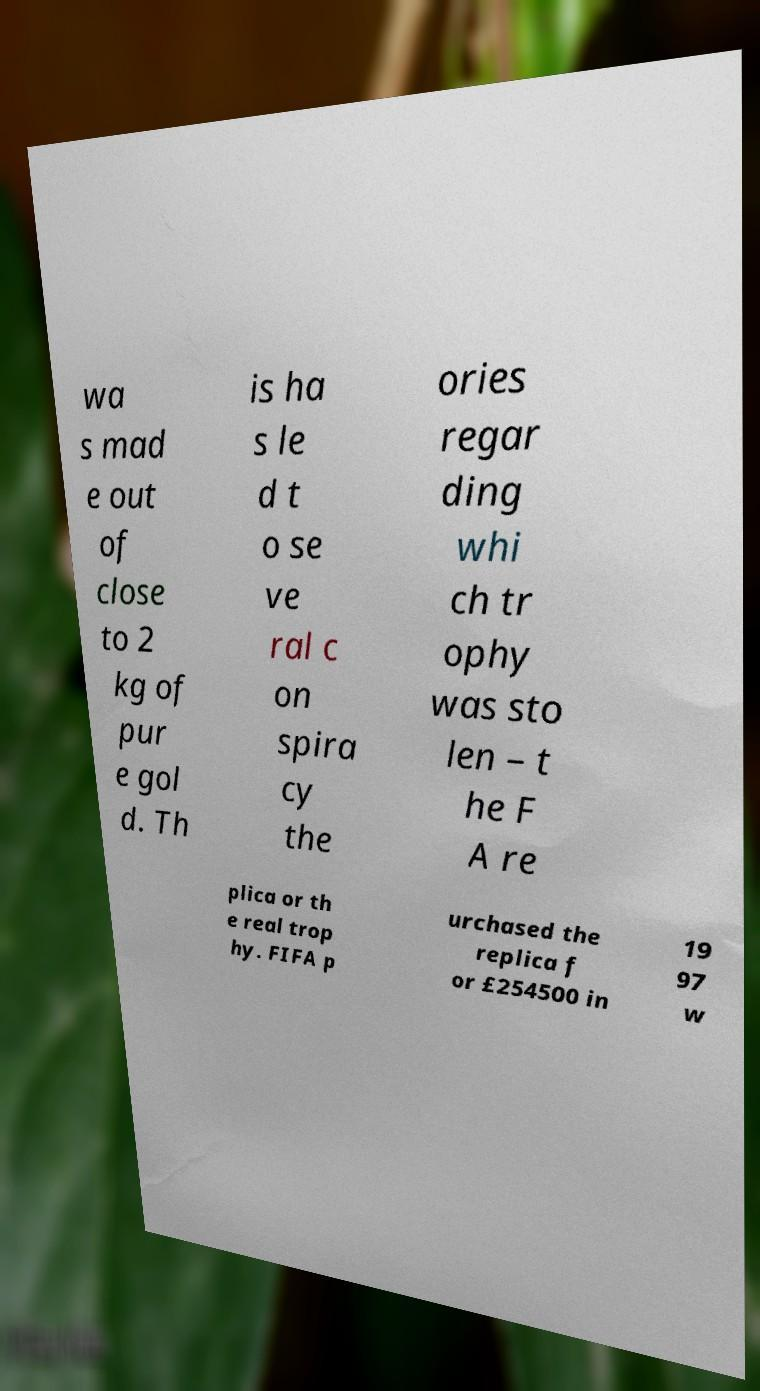Can you accurately transcribe the text from the provided image for me? wa s mad e out of close to 2 kg of pur e gol d. Th is ha s le d t o se ve ral c on spira cy the ories regar ding whi ch tr ophy was sto len – t he F A re plica or th e real trop hy. FIFA p urchased the replica f or £254500 in 19 97 w 